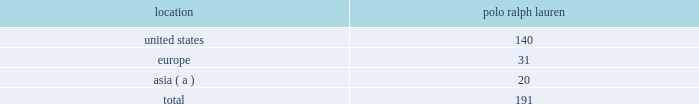Table of contents 2022 rugby is a vertical retail format featuring an aspirational lifestyle collection of apparel and accessories for men and women .
The brand is characterized by a youthful , preppy attitude which resonates throughout the line and the store experience .
In addition to generating sales of our products , our worldwide full-price stores set , reinforce and capitalize on the image of our brands .
Our stores range in size from approximately 800 to over 38000 square feet .
These full-price stores are situated in major upscale street locations and upscale regional malls , generally in large urban markets .
We generally lease our stores for initial periods ranging from 5 to 10 years with renewal options .
Factory retail stores we extend our reach to additional consumer groups through our 191 polo ralph lauren factory stores worldwide .
Our factory stores are generally located in outlet centers .
We generally lease our stores for initial periods ranging from 5 to 10 years with renewal options .
During fiscal 2011 , we added 19 new polo ralph lauren factory stores , net , and assumed 2 factory stores in connection with the south korea licensed operations acquisition ( see 201crecent developments 201d for further discussion ) .
We operated the following factory retail stores as of april 2 , 2011 : location ralph lauren .
( a ) includes japan , south korea , china , hong kong , indonesia , malaysia , the philippines , singapore , taiwan and thailand .
2022 polo ralph lauren domestic factory stores offer selections of our menswear , womenswear , children 2019s apparel , accessories , home furnishings and fragrances .
Ranging in size from approximately 2500 to 20000 square feet , with an average of approximately 9500 square feet , these stores are principally located in major outlet centers in 37 states and puerto rico .
2022 europe factory stores offer selections of our menswear , womenswear , children 2019s apparel , accessories , home furnishings and fragrances .
Ranging in size from approximately 2300 to 10500 square feet , with an average of approximately 6000 square feet , these stores are located in 11 countries , principally in major outlet centers .
2022 asia factory stores offer selections of our menswear , womenswear , children 2019s apparel , accessories and fragrances .
Ranging in size from approximately 1000 to 12000 square feet , with an average of approximately 5000 square feet , these stores are primarily located throughout japan and in or near other major cities within the asia-pacific region , principally in major outlet centers .
Factory stores obtain products from our suppliers , our product licensing partners and our retail and e-commerce stores .
Concessions-based shop-within-shops in asia , the terms of trade for shop-within-shops are largely conducted on a concessions basis , whereby inventory continues to be owned by us ( not the department store ) until ultimate sale to the end consumer and the salespeople involved in the sales transaction are generally our employees .
As of april 2 , 2011 , we had 510 concessions-based shop-within-shops at approximately 236 retail locations dedicated to our ralph lauren-branded products , primarily in asia , including 178 concessions-based shop-in-shops related to the south korea licensed operations acquisition .
The size of our concessions-based shop-within-shops typically ranges from approximately 180 to 3600 square feet .
We share in the cost of these shop-within-shops with our department store partners. .
What percentage of factory retail stores as of april 2 , 2011 is europe? 
Computations: (31 / 191)
Answer: 0.1623. 